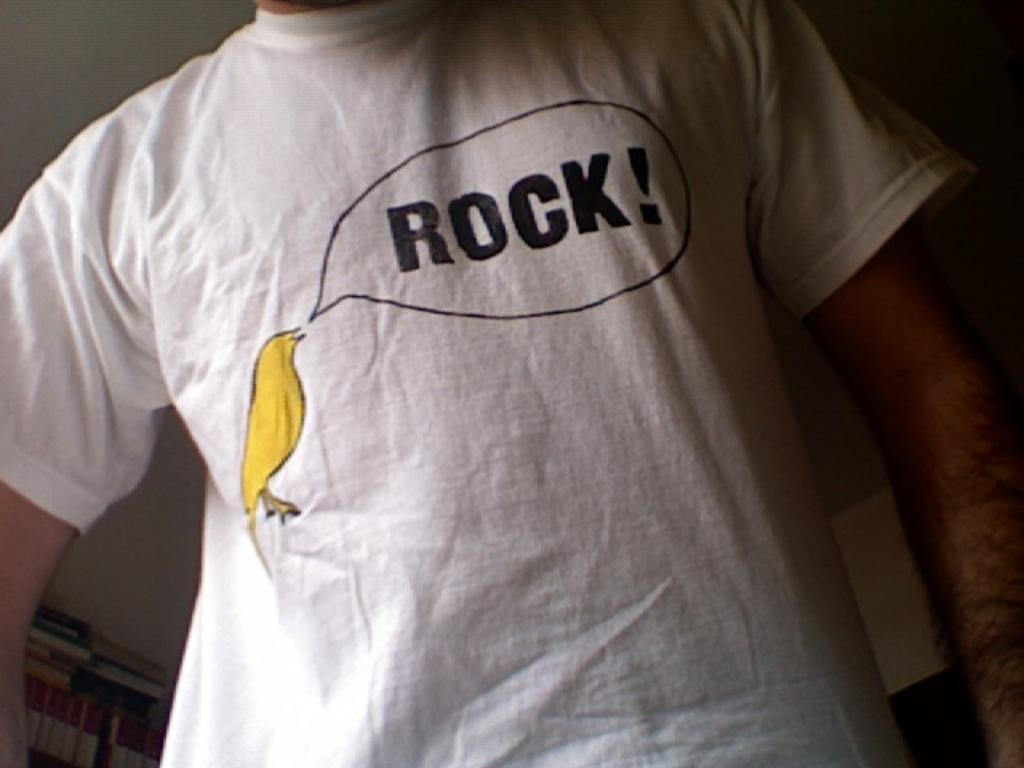<image>
Create a compact narrative representing the image presented. A white t-shirt shows a yellow bird saying "rock!" 